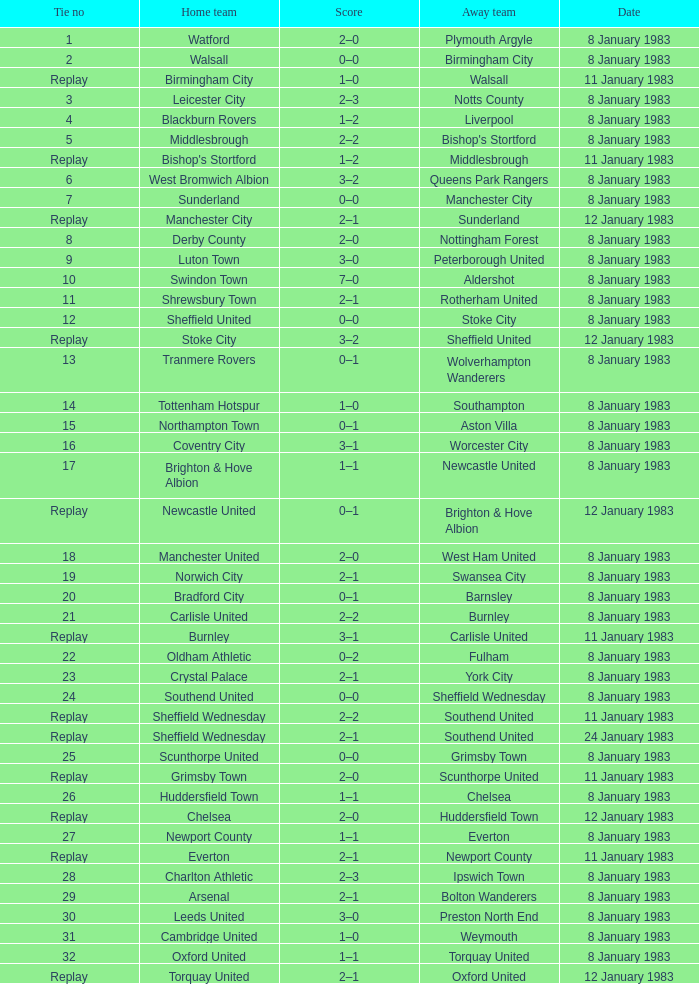What is the name of the visiting team in tie #19? Swansea City. 